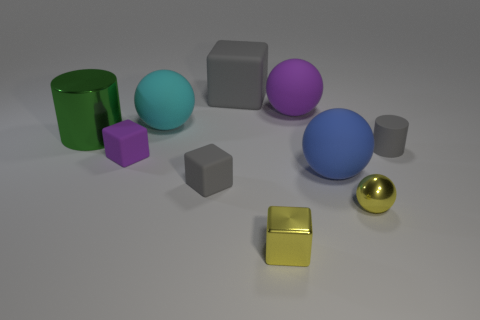Subtract all yellow metal cubes. How many cubes are left? 3 Subtract all green cylinders. How many gray cubes are left? 2 Subtract 2 balls. How many balls are left? 2 Subtract all yellow blocks. How many blocks are left? 3 Subtract all cylinders. How many objects are left? 8 Subtract all green balls. Subtract all red blocks. How many balls are left? 4 Add 3 tiny rubber things. How many tiny rubber things are left? 6 Add 6 tiny rubber things. How many tiny rubber things exist? 9 Subtract 0 red balls. How many objects are left? 10 Subtract all tiny purple matte things. Subtract all tiny gray cylinders. How many objects are left? 8 